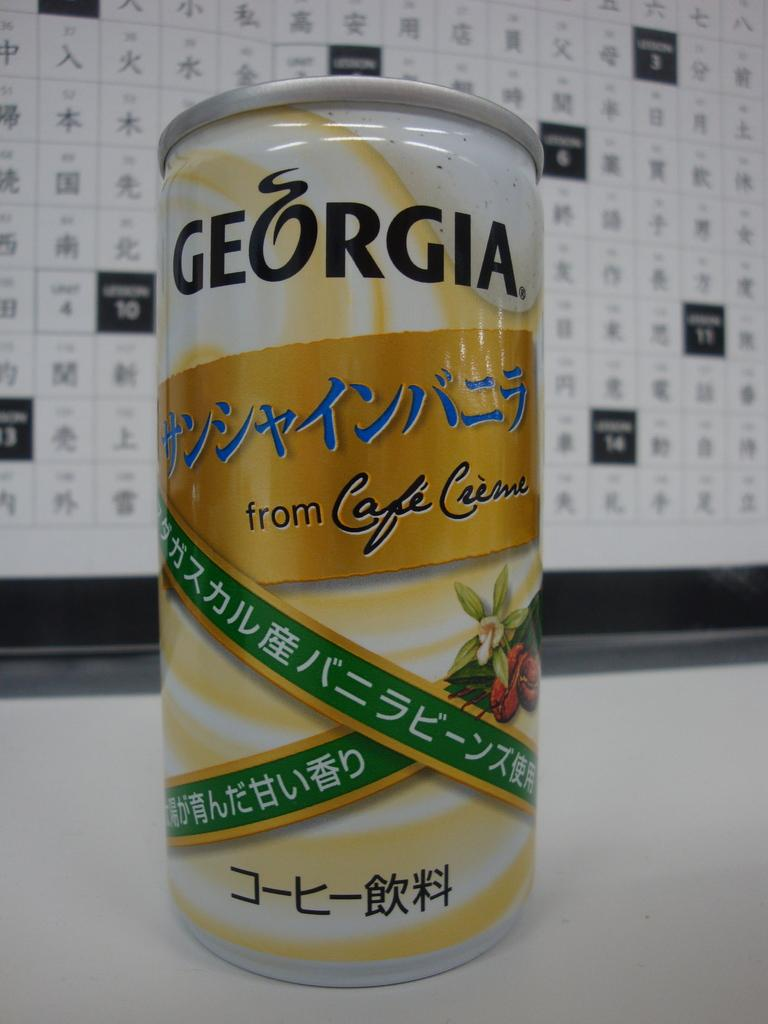<image>
Give a short and clear explanation of the subsequent image. a can that has the word Georgia on it 